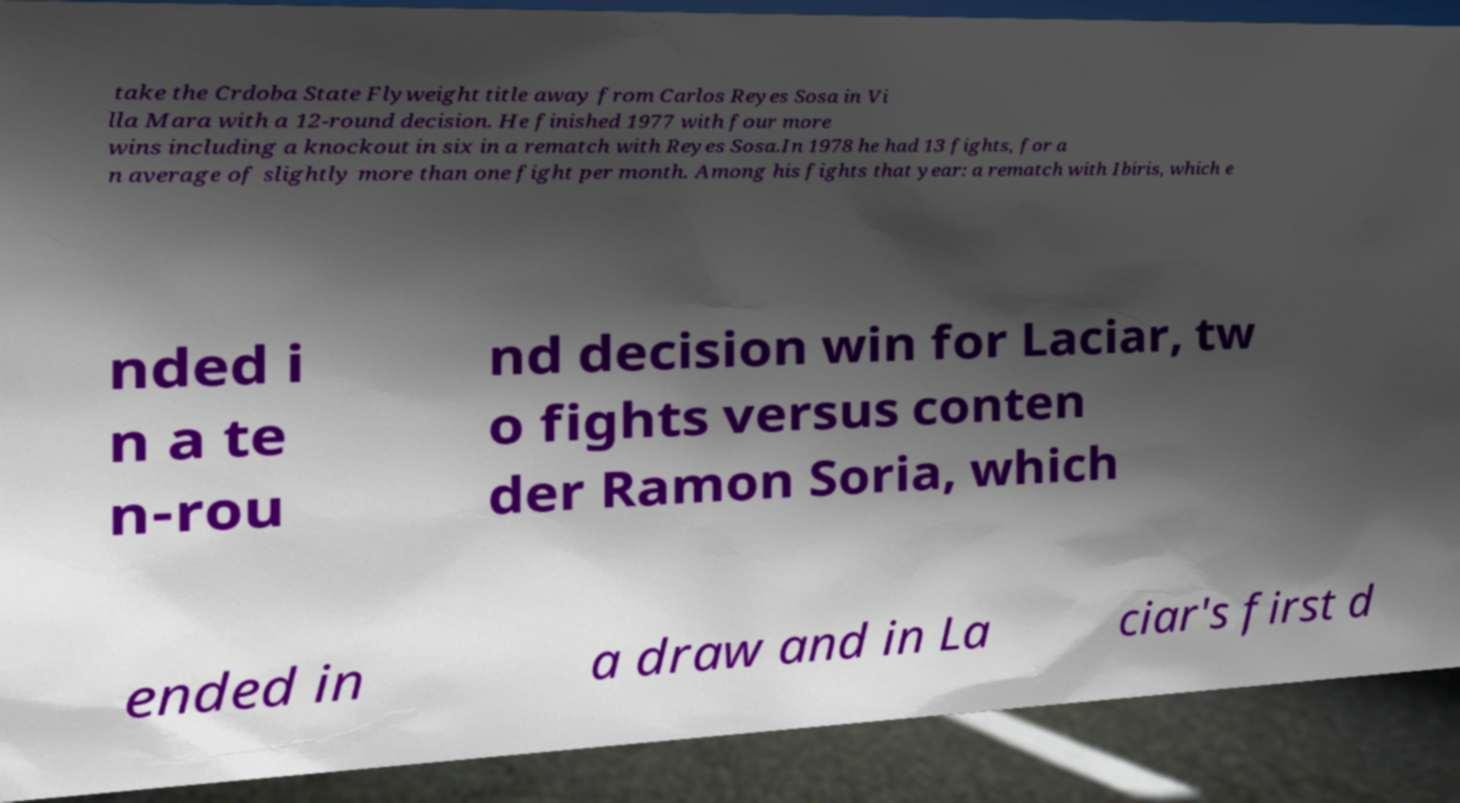What messages or text are displayed in this image? I need them in a readable, typed format. take the Crdoba State Flyweight title away from Carlos Reyes Sosa in Vi lla Mara with a 12-round decision. He finished 1977 with four more wins including a knockout in six in a rematch with Reyes Sosa.In 1978 he had 13 fights, for a n average of slightly more than one fight per month. Among his fights that year: a rematch with Ibiris, which e nded i n a te n-rou nd decision win for Laciar, tw o fights versus conten der Ramon Soria, which ended in a draw and in La ciar's first d 